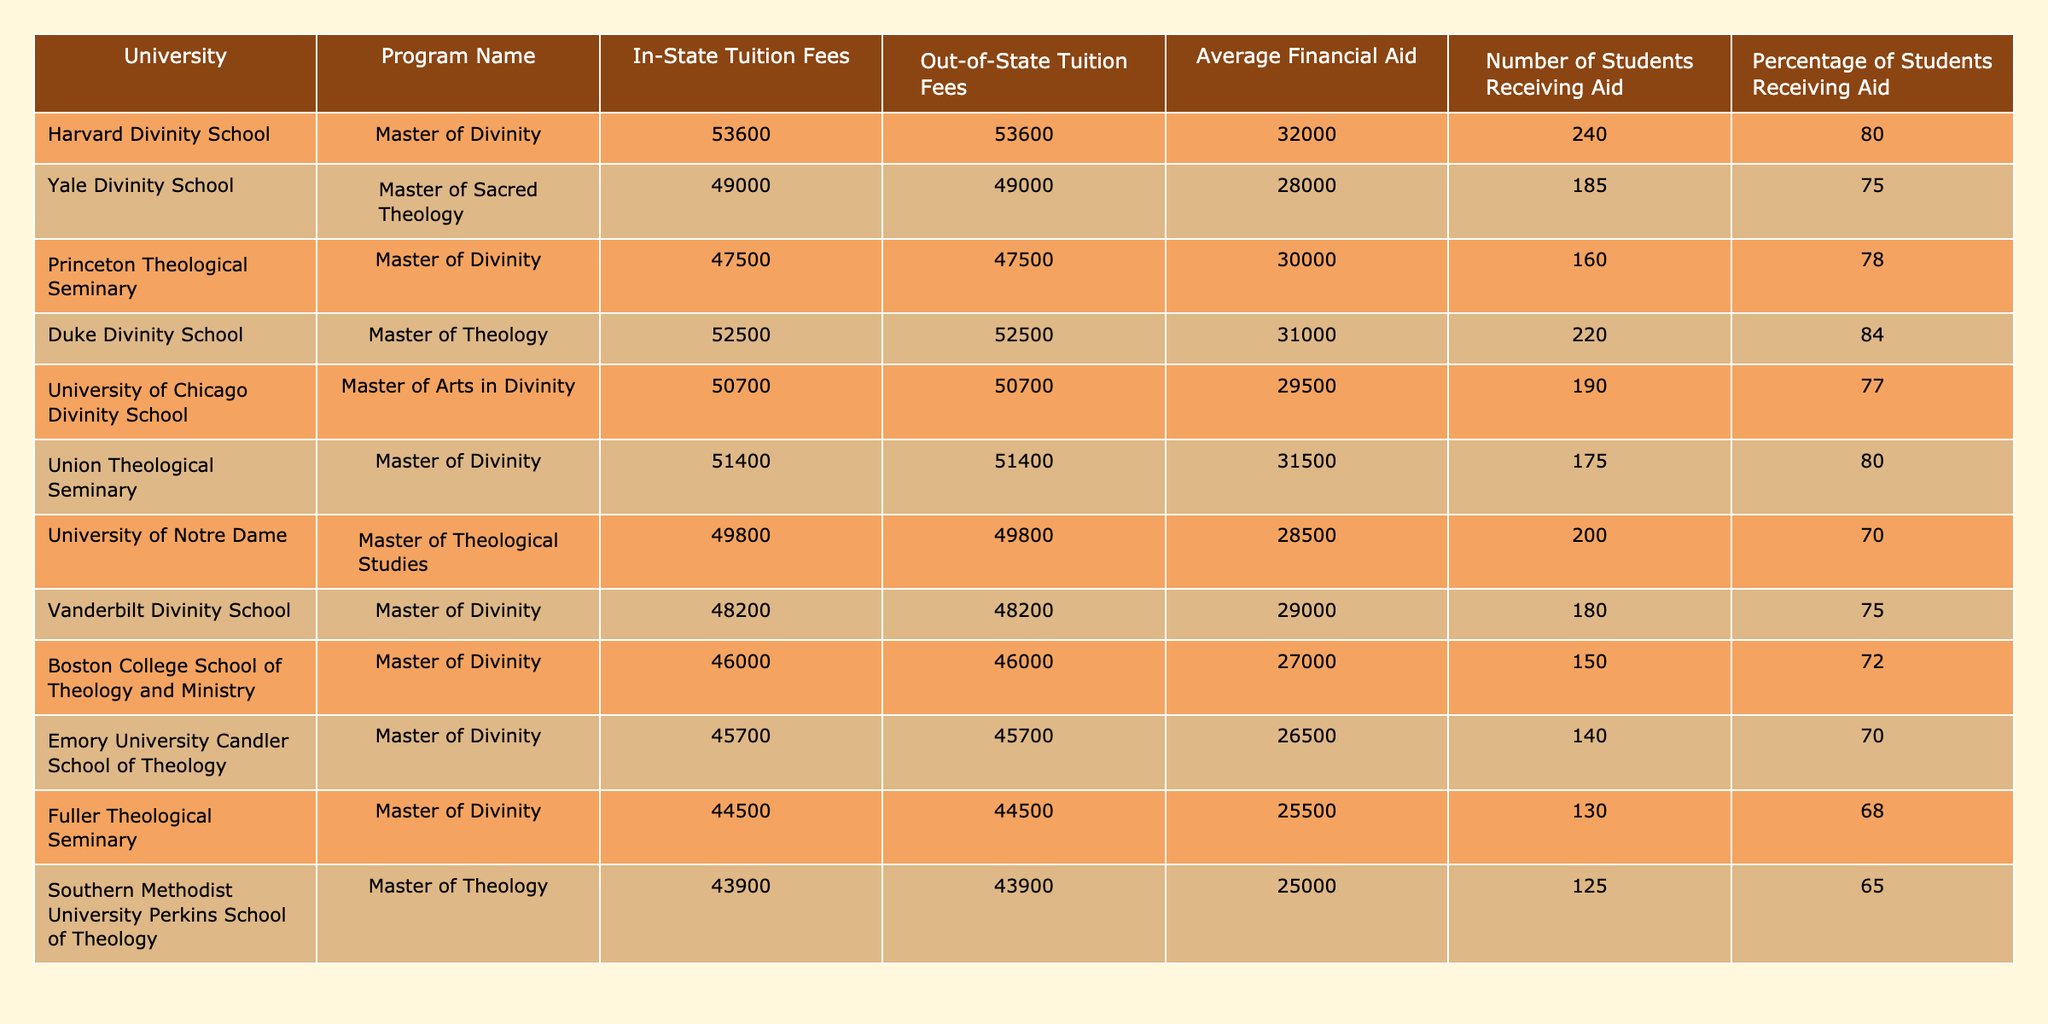What is the out-of-state tuition fee for Princeton Theological Seminary? The table lists Princeton Theological Seminary's out-of-state tuition fee directly in the corresponding column, which shows 47500.
Answer: 47500 Which university offers the highest average financial aid? To determine which university offers the highest average financial aid, we can observe the "Average Financial Aid" column across all universities. Harvard Divinity School has the highest amount at 32000.
Answer: Harvard Divinity School How many students at Fuller Theological Seminary receive financial aid? The table indicates that 130 students at Fuller Theological Seminary receive financial aid, as specified in the "Number of Students Receiving Aid" column.
Answer: 130 What is the average tuition fee for theology programs in the listed universities? To calculate the average tuition fees, we sum the in-state tuition fees of all universities (53600 + 49000 + 47500 + 52500 + 50700 + 51400 + 49800 + 48200 + 46000 + 45700 + 44500 + 43900) which totals 573600, and then divide by the number of universities (12): 573600 / 12 = 47800.
Answer: 47800 Is the percentage of students receiving aid at Emory University higher than that at Southern Methodist University? Emory University has 70% of its students receiving aid, while Southern Methodist University has 65%. Since 70% is greater than 65%, the answer is yes.
Answer: Yes Which program has the lowest percentage of students receiving aid? To find the program with the lowest percentage of students receiving aid, we examine the "Percentage of Students Receiving Aid" column. Southern Methodist University has the lowest at 65%.
Answer: Southern Methodist University What is the difference in average financial aid between Yale Divinity School and the University of Notre Dame? Yale Divinity School has an average financial aid of 28000, and the University of Notre Dame has 28500. The difference is calculated by subtracting (28500 - 28000) which equals 500.
Answer: 500 How many total students are receiving financial aid across all listed universities? To find the total number of students receiving financial aid, we sum the "Number of Students Receiving Aid" column (240 + 185 + 160 + 220 + 190 + 175 + 200 + 180 + 150 + 140 + 130 + 125), yielding a total of 1875 students.
Answer: 1875 Does Vanderbilt Divinity School have a higher out-of-state tuition fee than the University of Chicago Divinity School? Vanderbilt Divinity School's out-of-state tuition is 48200, while the University of Chicago Divinity School's out-of-state tuition is 50700. Since 48200 is less than 50700, Vanderbilt does not have a higher fee.
Answer: No 